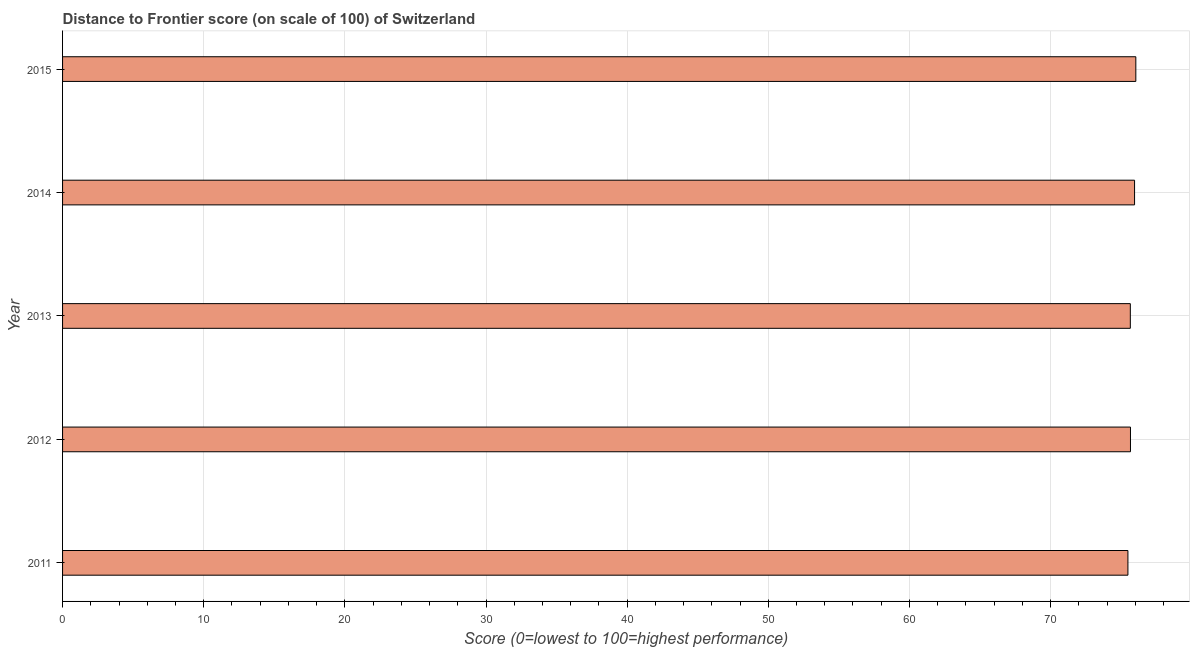Does the graph contain any zero values?
Keep it short and to the point. No. What is the title of the graph?
Provide a succinct answer. Distance to Frontier score (on scale of 100) of Switzerland. What is the label or title of the X-axis?
Provide a short and direct response. Score (0=lowest to 100=highest performance). What is the distance to frontier score in 2013?
Give a very brief answer. 75.65. Across all years, what is the maximum distance to frontier score?
Your answer should be compact. 76.04. Across all years, what is the minimum distance to frontier score?
Offer a terse response. 75.48. In which year was the distance to frontier score maximum?
Your answer should be compact. 2015. What is the sum of the distance to frontier score?
Offer a very short reply. 378.78. What is the difference between the distance to frontier score in 2011 and 2013?
Give a very brief answer. -0.17. What is the average distance to frontier score per year?
Your answer should be very brief. 75.76. What is the median distance to frontier score?
Keep it short and to the point. 75.66. Do a majority of the years between 2015 and 2011 (inclusive) have distance to frontier score greater than 14 ?
Keep it short and to the point. Yes. Is the distance to frontier score in 2013 less than that in 2014?
Provide a succinct answer. Yes. What is the difference between the highest and the second highest distance to frontier score?
Provide a succinct answer. 0.09. What is the difference between the highest and the lowest distance to frontier score?
Give a very brief answer. 0.56. In how many years, is the distance to frontier score greater than the average distance to frontier score taken over all years?
Provide a short and direct response. 2. Are the values on the major ticks of X-axis written in scientific E-notation?
Make the answer very short. No. What is the Score (0=lowest to 100=highest performance) in 2011?
Your answer should be compact. 75.48. What is the Score (0=lowest to 100=highest performance) of 2012?
Your answer should be very brief. 75.66. What is the Score (0=lowest to 100=highest performance) in 2013?
Give a very brief answer. 75.65. What is the Score (0=lowest to 100=highest performance) in 2014?
Your answer should be compact. 75.95. What is the Score (0=lowest to 100=highest performance) of 2015?
Offer a very short reply. 76.04. What is the difference between the Score (0=lowest to 100=highest performance) in 2011 and 2012?
Ensure brevity in your answer.  -0.18. What is the difference between the Score (0=lowest to 100=highest performance) in 2011 and 2013?
Ensure brevity in your answer.  -0.17. What is the difference between the Score (0=lowest to 100=highest performance) in 2011 and 2014?
Keep it short and to the point. -0.47. What is the difference between the Score (0=lowest to 100=highest performance) in 2011 and 2015?
Your response must be concise. -0.56. What is the difference between the Score (0=lowest to 100=highest performance) in 2012 and 2014?
Your answer should be compact. -0.29. What is the difference between the Score (0=lowest to 100=highest performance) in 2012 and 2015?
Make the answer very short. -0.38. What is the difference between the Score (0=lowest to 100=highest performance) in 2013 and 2015?
Provide a short and direct response. -0.39. What is the difference between the Score (0=lowest to 100=highest performance) in 2014 and 2015?
Give a very brief answer. -0.09. What is the ratio of the Score (0=lowest to 100=highest performance) in 2011 to that in 2012?
Your answer should be very brief. 1. What is the ratio of the Score (0=lowest to 100=highest performance) in 2011 to that in 2013?
Give a very brief answer. 1. What is the ratio of the Score (0=lowest to 100=highest performance) in 2011 to that in 2014?
Your answer should be compact. 0.99. What is the ratio of the Score (0=lowest to 100=highest performance) in 2012 to that in 2014?
Your answer should be compact. 1. What is the ratio of the Score (0=lowest to 100=highest performance) in 2013 to that in 2014?
Your answer should be compact. 1. What is the ratio of the Score (0=lowest to 100=highest performance) in 2014 to that in 2015?
Provide a short and direct response. 1. 